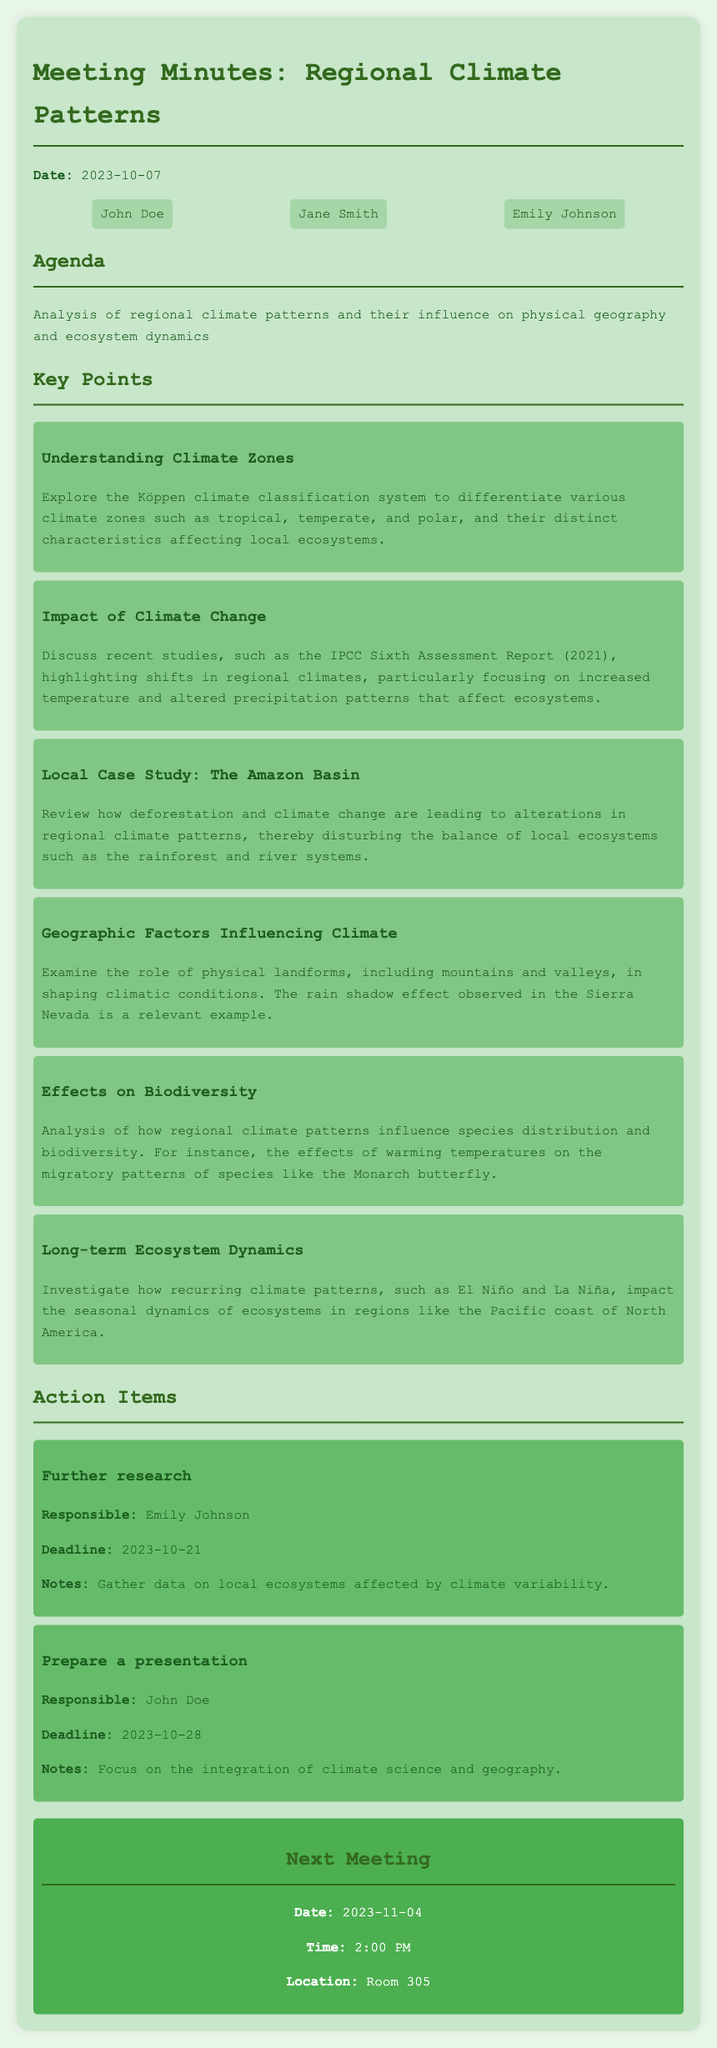What date was the meeting held? The meeting date is mentioned at the beginning of the document, which is October 7, 2023.
Answer: 2023-10-07 Who is responsible for the further research action item? The action item for further research lists Emily Johnson as responsible.
Answer: Emily Johnson What climate classification system is explored in the meeting? The key points section mentions the Köppen climate classification system in relation to climate zones.
Answer: Köppen climate classification What is the deadline for preparing a presentation? The document states the deadline for the presentation preparation is October 28, 2023.
Answer: 2023-10-28 Which local case study is reviewed in this meeting? The meeting discusses the Amazon Basin as a local case study.
Answer: The Amazon Basin What phenomenon is mentioned that impacts ecosystem dynamics? The key points discussion refers to the effects of El Niño and La Niña on ecosystems.
Answer: El Niño and La Niña What is the next meeting date? The document clearly states the next meeting is scheduled for November 4, 2023.
Answer: 2023-11-04 How many participants are listed in the document? The participants listed include three individuals, as seen in the participant section.
Answer: Three What is a geographic factor influencing climate mentioned? The key points note mountains and valleys as geographic factors influencing climate.
Answer: Mountains and valleys 